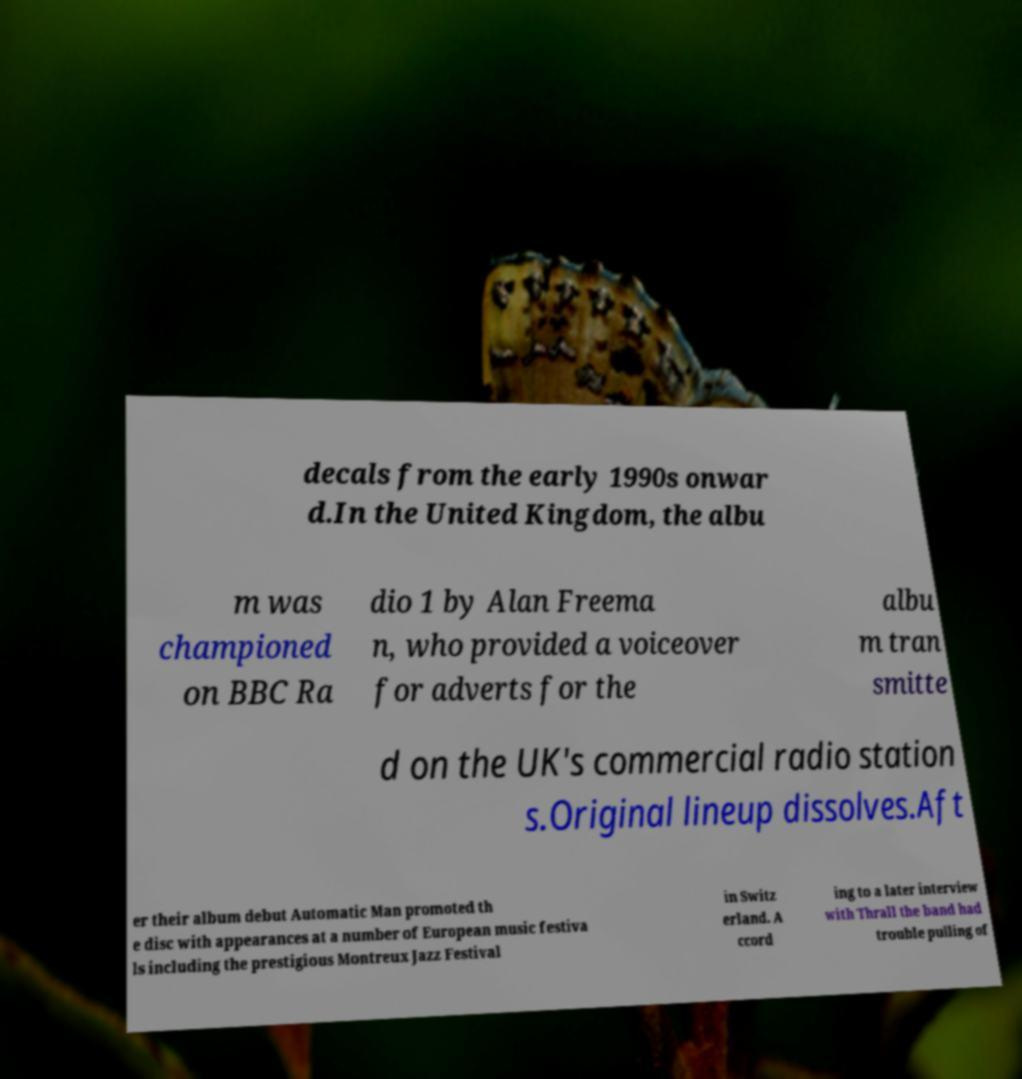Can you accurately transcribe the text from the provided image for me? decals from the early 1990s onwar d.In the United Kingdom, the albu m was championed on BBC Ra dio 1 by Alan Freema n, who provided a voiceover for adverts for the albu m tran smitte d on the UK's commercial radio station s.Original lineup dissolves.Aft er their album debut Automatic Man promoted th e disc with appearances at a number of European music festiva ls including the prestigious Montreux Jazz Festival in Switz erland. A ccord ing to a later interview with Thrall the band had trouble pulling of 